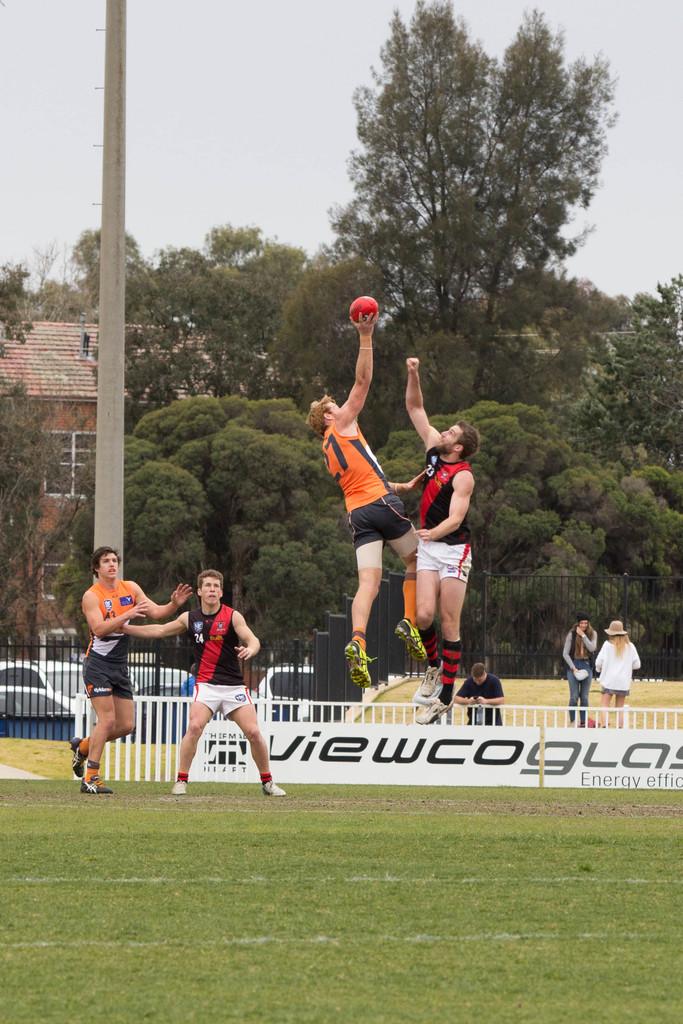Who sponsors the field?
Your answer should be compact. Viewcoglass. 